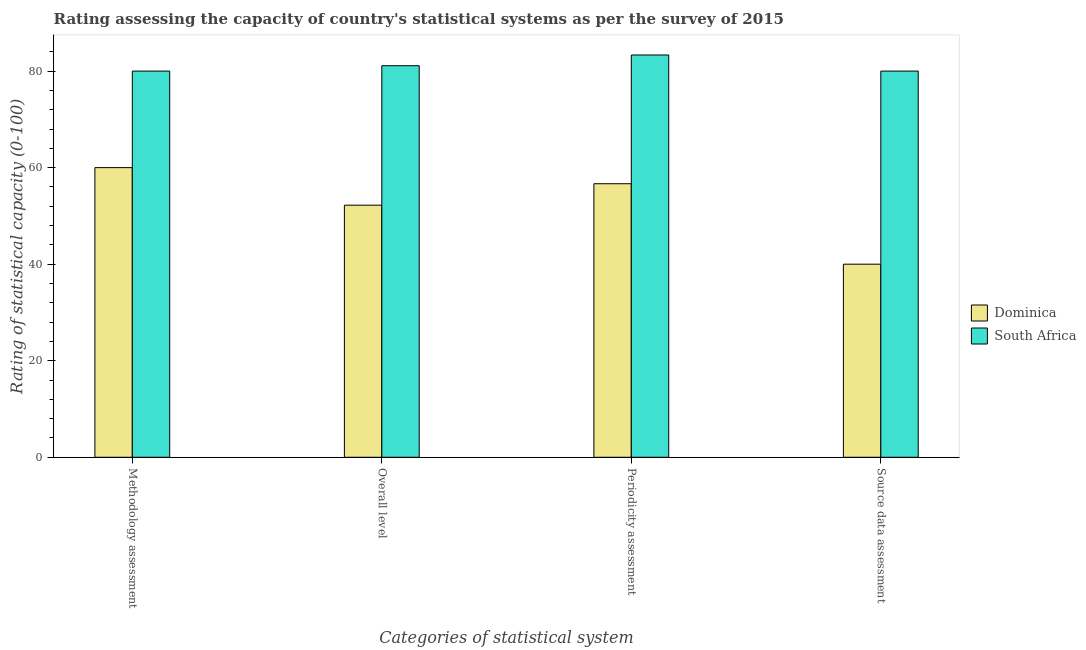How many groups of bars are there?
Keep it short and to the point. 4. Are the number of bars per tick equal to the number of legend labels?
Offer a terse response. Yes. Are the number of bars on each tick of the X-axis equal?
Offer a very short reply. Yes. How many bars are there on the 3rd tick from the left?
Provide a succinct answer. 2. How many bars are there on the 2nd tick from the right?
Provide a succinct answer. 2. What is the label of the 1st group of bars from the left?
Give a very brief answer. Methodology assessment. What is the periodicity assessment rating in South Africa?
Give a very brief answer. 83.33. Across all countries, what is the maximum methodology assessment rating?
Offer a very short reply. 80. In which country was the methodology assessment rating maximum?
Give a very brief answer. South Africa. In which country was the periodicity assessment rating minimum?
Your response must be concise. Dominica. What is the total methodology assessment rating in the graph?
Your answer should be very brief. 140. What is the difference between the source data assessment rating in South Africa and that in Dominica?
Ensure brevity in your answer.  40. What is the difference between the source data assessment rating in South Africa and the overall level rating in Dominica?
Keep it short and to the point. 27.78. What is the difference between the source data assessment rating and overall level rating in South Africa?
Give a very brief answer. -1.11. What is the ratio of the overall level rating in Dominica to that in South Africa?
Your answer should be compact. 0.64. Is the overall level rating in Dominica less than that in South Africa?
Offer a very short reply. Yes. What is the difference between the highest and the second highest periodicity assessment rating?
Your answer should be compact. 26.67. What is the difference between the highest and the lowest methodology assessment rating?
Your answer should be compact. 20. In how many countries, is the source data assessment rating greater than the average source data assessment rating taken over all countries?
Offer a terse response. 1. What does the 2nd bar from the left in Source data assessment represents?
Your response must be concise. South Africa. What does the 1st bar from the right in Periodicity assessment represents?
Provide a succinct answer. South Africa. Is it the case that in every country, the sum of the methodology assessment rating and overall level rating is greater than the periodicity assessment rating?
Make the answer very short. Yes. Are all the bars in the graph horizontal?
Your answer should be compact. No. What is the difference between two consecutive major ticks on the Y-axis?
Keep it short and to the point. 20. Are the values on the major ticks of Y-axis written in scientific E-notation?
Offer a very short reply. No. Does the graph contain any zero values?
Offer a very short reply. No. Does the graph contain grids?
Keep it short and to the point. No. What is the title of the graph?
Make the answer very short. Rating assessing the capacity of country's statistical systems as per the survey of 2015 . What is the label or title of the X-axis?
Provide a short and direct response. Categories of statistical system. What is the label or title of the Y-axis?
Keep it short and to the point. Rating of statistical capacity (0-100). What is the Rating of statistical capacity (0-100) in South Africa in Methodology assessment?
Provide a short and direct response. 80. What is the Rating of statistical capacity (0-100) in Dominica in Overall level?
Your answer should be very brief. 52.22. What is the Rating of statistical capacity (0-100) in South Africa in Overall level?
Provide a succinct answer. 81.11. What is the Rating of statistical capacity (0-100) of Dominica in Periodicity assessment?
Provide a succinct answer. 56.67. What is the Rating of statistical capacity (0-100) of South Africa in Periodicity assessment?
Provide a succinct answer. 83.33. What is the Rating of statistical capacity (0-100) of Dominica in Source data assessment?
Offer a very short reply. 40. What is the Rating of statistical capacity (0-100) of South Africa in Source data assessment?
Ensure brevity in your answer.  80. Across all Categories of statistical system, what is the maximum Rating of statistical capacity (0-100) in Dominica?
Provide a succinct answer. 60. Across all Categories of statistical system, what is the maximum Rating of statistical capacity (0-100) of South Africa?
Make the answer very short. 83.33. Across all Categories of statistical system, what is the minimum Rating of statistical capacity (0-100) of South Africa?
Make the answer very short. 80. What is the total Rating of statistical capacity (0-100) of Dominica in the graph?
Give a very brief answer. 208.89. What is the total Rating of statistical capacity (0-100) in South Africa in the graph?
Offer a very short reply. 324.44. What is the difference between the Rating of statistical capacity (0-100) of Dominica in Methodology assessment and that in Overall level?
Your answer should be very brief. 7.78. What is the difference between the Rating of statistical capacity (0-100) of South Africa in Methodology assessment and that in Overall level?
Ensure brevity in your answer.  -1.11. What is the difference between the Rating of statistical capacity (0-100) in Dominica in Methodology assessment and that in Periodicity assessment?
Your answer should be compact. 3.33. What is the difference between the Rating of statistical capacity (0-100) in South Africa in Methodology assessment and that in Source data assessment?
Offer a very short reply. 0. What is the difference between the Rating of statistical capacity (0-100) in Dominica in Overall level and that in Periodicity assessment?
Keep it short and to the point. -4.44. What is the difference between the Rating of statistical capacity (0-100) in South Africa in Overall level and that in Periodicity assessment?
Give a very brief answer. -2.22. What is the difference between the Rating of statistical capacity (0-100) of Dominica in Overall level and that in Source data assessment?
Give a very brief answer. 12.22. What is the difference between the Rating of statistical capacity (0-100) of Dominica in Periodicity assessment and that in Source data assessment?
Your answer should be very brief. 16.67. What is the difference between the Rating of statistical capacity (0-100) of Dominica in Methodology assessment and the Rating of statistical capacity (0-100) of South Africa in Overall level?
Offer a very short reply. -21.11. What is the difference between the Rating of statistical capacity (0-100) of Dominica in Methodology assessment and the Rating of statistical capacity (0-100) of South Africa in Periodicity assessment?
Your answer should be very brief. -23.33. What is the difference between the Rating of statistical capacity (0-100) of Dominica in Methodology assessment and the Rating of statistical capacity (0-100) of South Africa in Source data assessment?
Your answer should be very brief. -20. What is the difference between the Rating of statistical capacity (0-100) in Dominica in Overall level and the Rating of statistical capacity (0-100) in South Africa in Periodicity assessment?
Provide a short and direct response. -31.11. What is the difference between the Rating of statistical capacity (0-100) of Dominica in Overall level and the Rating of statistical capacity (0-100) of South Africa in Source data assessment?
Your answer should be very brief. -27.78. What is the difference between the Rating of statistical capacity (0-100) of Dominica in Periodicity assessment and the Rating of statistical capacity (0-100) of South Africa in Source data assessment?
Your answer should be very brief. -23.33. What is the average Rating of statistical capacity (0-100) in Dominica per Categories of statistical system?
Give a very brief answer. 52.22. What is the average Rating of statistical capacity (0-100) of South Africa per Categories of statistical system?
Keep it short and to the point. 81.11. What is the difference between the Rating of statistical capacity (0-100) in Dominica and Rating of statistical capacity (0-100) in South Africa in Methodology assessment?
Provide a succinct answer. -20. What is the difference between the Rating of statistical capacity (0-100) in Dominica and Rating of statistical capacity (0-100) in South Africa in Overall level?
Give a very brief answer. -28.89. What is the difference between the Rating of statistical capacity (0-100) in Dominica and Rating of statistical capacity (0-100) in South Africa in Periodicity assessment?
Provide a succinct answer. -26.67. What is the ratio of the Rating of statistical capacity (0-100) of Dominica in Methodology assessment to that in Overall level?
Provide a succinct answer. 1.15. What is the ratio of the Rating of statistical capacity (0-100) in South Africa in Methodology assessment to that in Overall level?
Your response must be concise. 0.99. What is the ratio of the Rating of statistical capacity (0-100) in Dominica in Methodology assessment to that in Periodicity assessment?
Your response must be concise. 1.06. What is the ratio of the Rating of statistical capacity (0-100) of Dominica in Overall level to that in Periodicity assessment?
Give a very brief answer. 0.92. What is the ratio of the Rating of statistical capacity (0-100) of South Africa in Overall level to that in Periodicity assessment?
Provide a succinct answer. 0.97. What is the ratio of the Rating of statistical capacity (0-100) in Dominica in Overall level to that in Source data assessment?
Your response must be concise. 1.31. What is the ratio of the Rating of statistical capacity (0-100) in South Africa in Overall level to that in Source data assessment?
Make the answer very short. 1.01. What is the ratio of the Rating of statistical capacity (0-100) in Dominica in Periodicity assessment to that in Source data assessment?
Your answer should be compact. 1.42. What is the ratio of the Rating of statistical capacity (0-100) in South Africa in Periodicity assessment to that in Source data assessment?
Offer a very short reply. 1.04. What is the difference between the highest and the second highest Rating of statistical capacity (0-100) in South Africa?
Your response must be concise. 2.22. What is the difference between the highest and the lowest Rating of statistical capacity (0-100) in South Africa?
Offer a terse response. 3.33. 